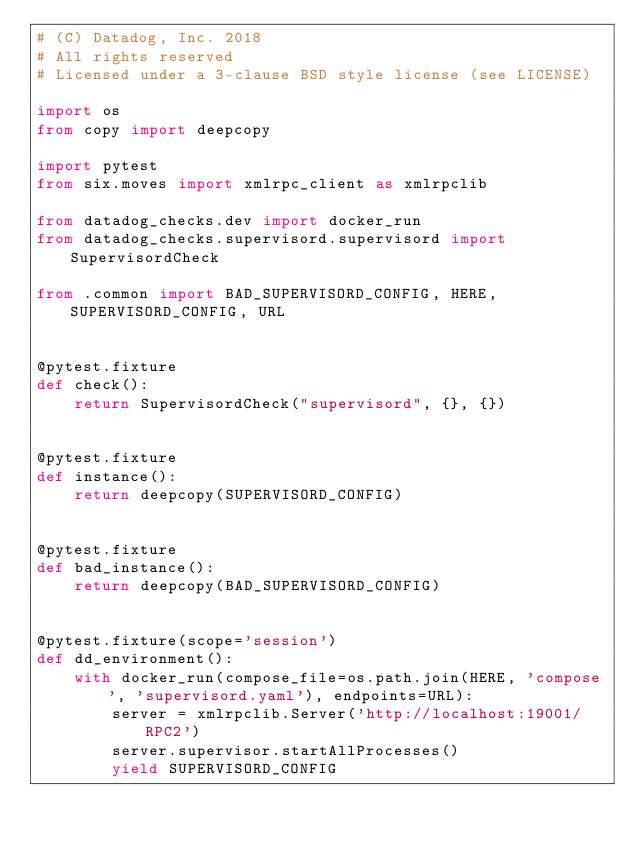<code> <loc_0><loc_0><loc_500><loc_500><_Python_># (C) Datadog, Inc. 2018
# All rights reserved
# Licensed under a 3-clause BSD style license (see LICENSE)

import os
from copy import deepcopy

import pytest
from six.moves import xmlrpc_client as xmlrpclib

from datadog_checks.dev import docker_run
from datadog_checks.supervisord.supervisord import SupervisordCheck

from .common import BAD_SUPERVISORD_CONFIG, HERE, SUPERVISORD_CONFIG, URL


@pytest.fixture
def check():
    return SupervisordCheck("supervisord", {}, {})


@pytest.fixture
def instance():
    return deepcopy(SUPERVISORD_CONFIG)


@pytest.fixture
def bad_instance():
    return deepcopy(BAD_SUPERVISORD_CONFIG)


@pytest.fixture(scope='session')
def dd_environment():
    with docker_run(compose_file=os.path.join(HERE, 'compose', 'supervisord.yaml'), endpoints=URL):
        server = xmlrpclib.Server('http://localhost:19001/RPC2')
        server.supervisor.startAllProcesses()
        yield SUPERVISORD_CONFIG
</code> 